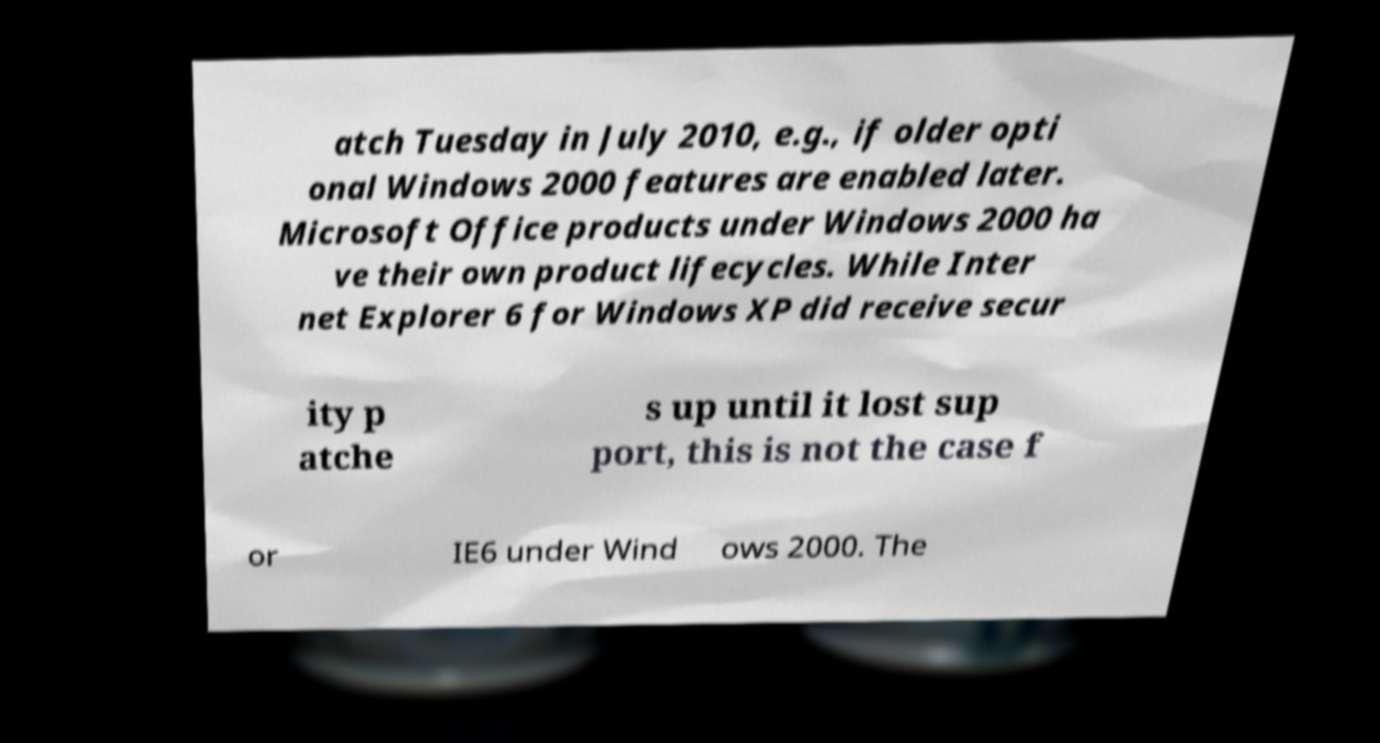Could you assist in decoding the text presented in this image and type it out clearly? atch Tuesday in July 2010, e.g., if older opti onal Windows 2000 features are enabled later. Microsoft Office products under Windows 2000 ha ve their own product lifecycles. While Inter net Explorer 6 for Windows XP did receive secur ity p atche s up until it lost sup port, this is not the case f or IE6 under Wind ows 2000. The 